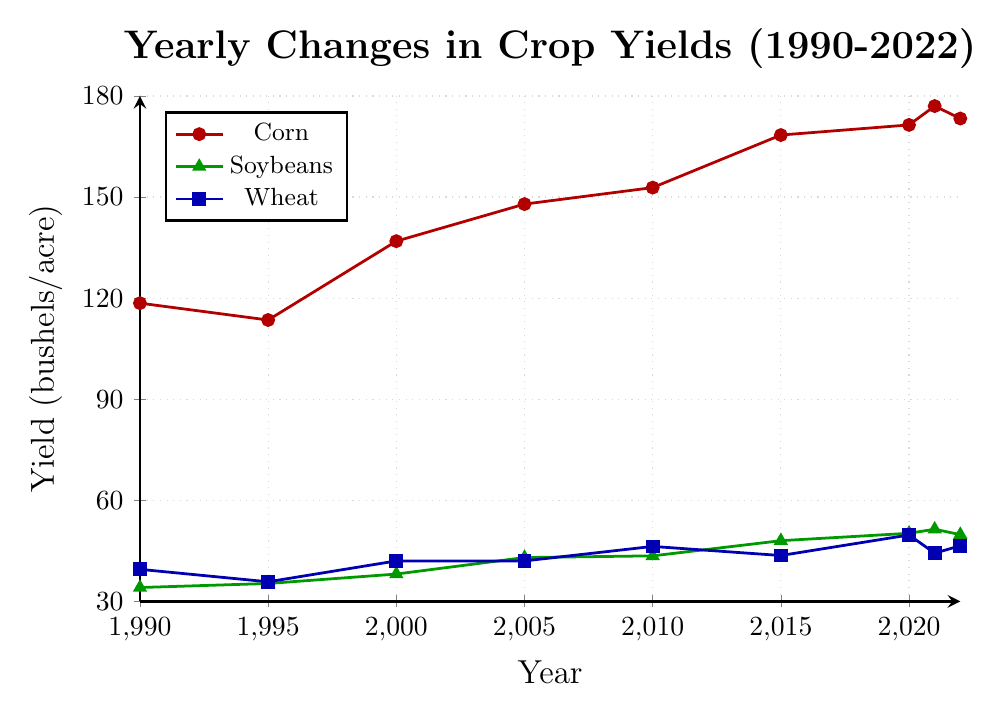How has the yield of corn changed from 1990 to 2022? To find how the yield of corn has changed from 1990 to 2022, compare the yield in 1990 (118.5 bushels/acre) to the yield in 2022 (173.3 bushels/acre). The yield increased over this period.
Answer: The yield increased Between which years did soybeans experience the greatest increase in yield? Identify the largest difference between consecutive years for soybeans. From 2005 to 2010, soybeans increased from 43.0 to 43.5 bushels/acre (0.5 bushels), while from 2010 to 2015, they increased from 43.5 to 48.0 bushels/acre (4.5 bushels). Hence, the greatest increase occurred between 2010 and 2015.
Answer: 2010 to 2015 Which crop had the highest yield in 2020? Check the yields of all three crops in 2020: Corn (171.4 bushels/acre), Soybeans (50.2 bushels/acre), and Wheat (49.7 bushels/acre). Corn had the highest yield.
Answer: Corn What is the average yield of wheat from 1990 to 2022? Sum the wheat yields from all given years (39.5 + 35.8 + 42.0 + 42.0 + 46.3 + 43.6 + 49.7 + 44.3 + 46.5) to get 389.7. Divide by the number of years (9). The average yield is calculated as 389.7 / 9 ≈ 43.3 bushels/acre.
Answer: 43.3 bushels/acre In which year did corn yield surpass 150 bushels/acre for the first time? Review the yields for corn each year and find the year when it first exceeds 150 bushels/acre. In 2010, the yield was 152.8 bushels/acre, which is the first year it surpassed 150.
Answer: 2010 Compare the yield of soybeans in 1995 and 2022. Which year had a higher yield? Soybean yield in 1995 was 35.3 bushels/acre, and in 2022 it was 49.8 bushels/acre. Compare these values to determine which is higher. The yield in 2022 was higher.
Answer: 2022 Between which consecutive years did wheat show a decrease in yield? Check the yield of wheat year by year to find decreases. The yield decreased between 1990 (39.5) and 1995 (35.8), and between 2020 (49.7) and 2021 (44.3).
Answer: 1990 to 1995 and 2020 to 2021 By how much did the yield of corn increase from 2015 to 2020? Compare the yield in 2015 (168.4 bushels/acre) and 2020 (171.4 bushels/acre). Subtract the 2015 yield from the 2020 yield to find the increase: 171.4 - 168.4 = 3 bushels/acre.
Answer: 3 bushels/acre What is the overall trend in soybean yields from 1990 to 2022? Notice the yearly soybean yields: they generally increase from 34.1 bushels/acre in 1990 to 49.8 bushels/acre in 2022, indicating an upward trend.
Answer: Upward trend 